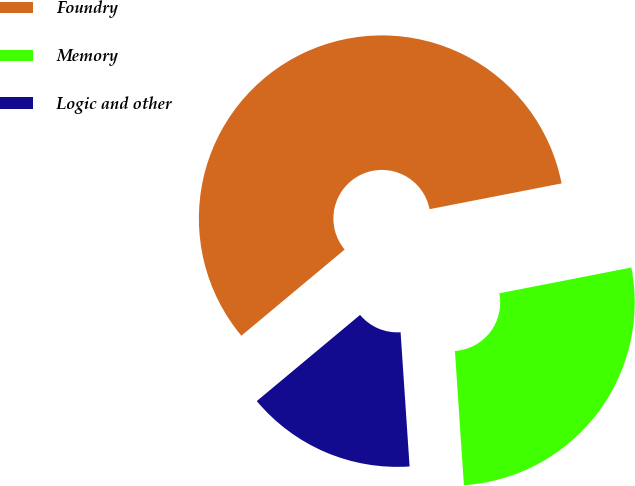Convert chart to OTSL. <chart><loc_0><loc_0><loc_500><loc_500><pie_chart><fcel>Foundry<fcel>Memory<fcel>Logic and other<nl><fcel>58.0%<fcel>27.0%<fcel>15.0%<nl></chart> 